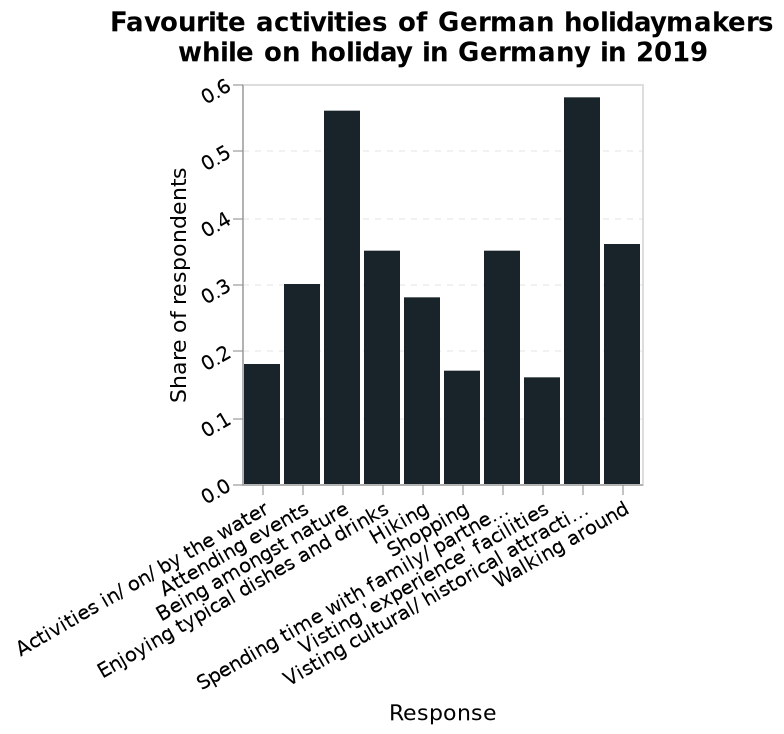<image>
What is the topic of the bar graph? The topic of the bar graph is the "Favourite activities of German holidaymakers while on holiday in Germany in 2019." 